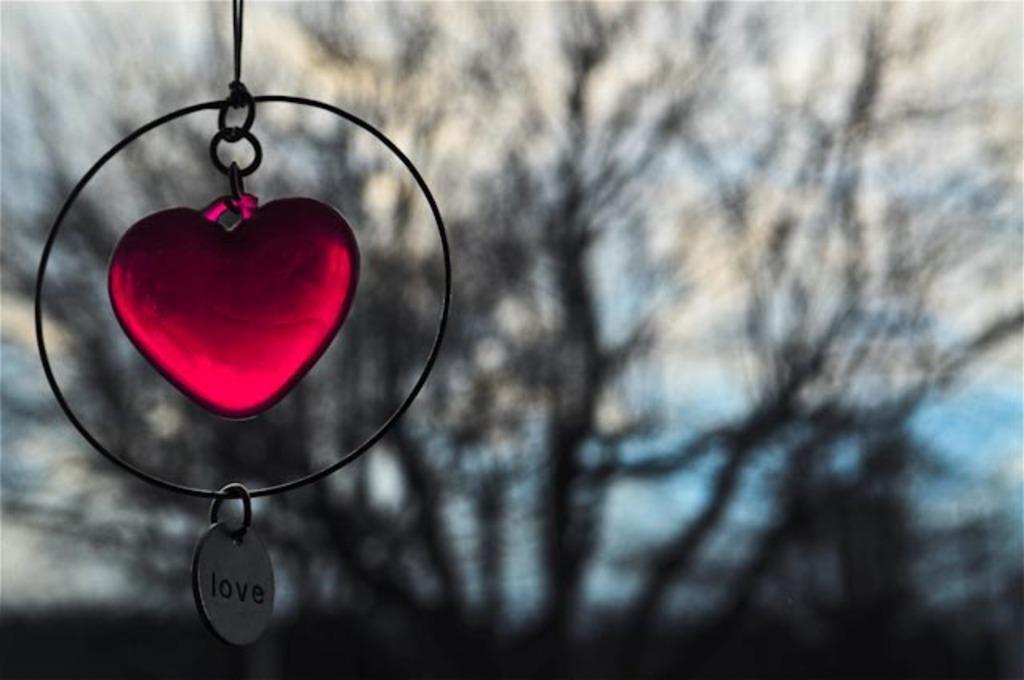Please provide a concise description of this image. In this image I can see an object in red and black color. In the background I can see few trees and the sky is in blue and white color. 